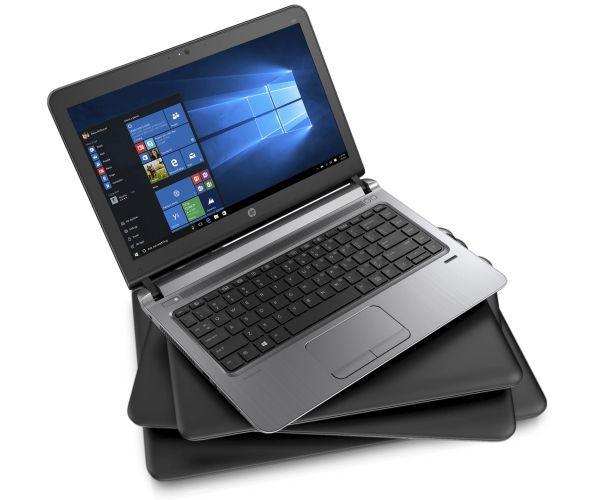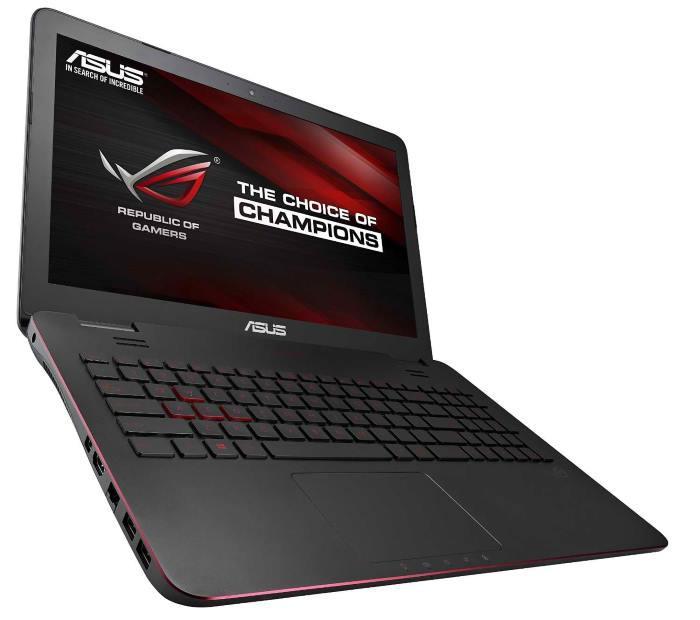The first image is the image on the left, the second image is the image on the right. Examine the images to the left and right. Is the description "The left image contains one leftward-facing open laptop with a mostly black screen, and the right image contains one leftward-facing laptop with a mostly blue screen." accurate? Answer yes or no. No. The first image is the image on the left, the second image is the image on the right. Considering the images on both sides, is "In at least one image there is an open laptop with a blue background, thats bottom is silver and frame around the screen is black." valid? Answer yes or no. Yes. 